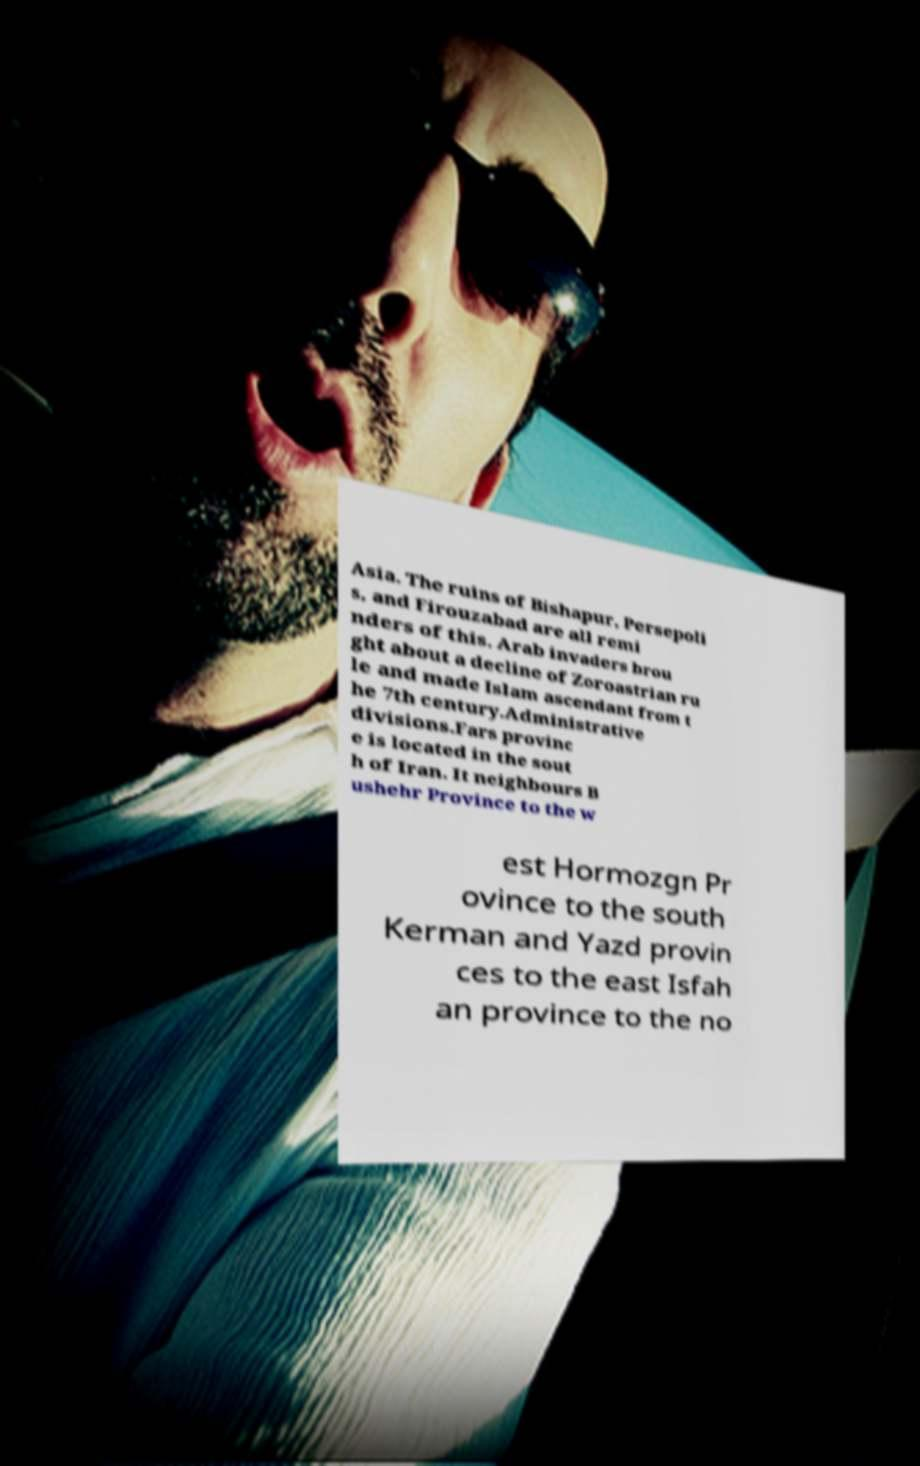There's text embedded in this image that I need extracted. Can you transcribe it verbatim? Asia. The ruins of Bishapur, Persepoli s, and Firouzabad are all remi nders of this. Arab invaders brou ght about a decline of Zoroastrian ru le and made Islam ascendant from t he 7th century.Administrative divisions.Fars provinc e is located in the sout h of Iran. It neighbours B ushehr Province to the w est Hormozgn Pr ovince to the south Kerman and Yazd provin ces to the east Isfah an province to the no 